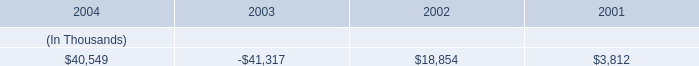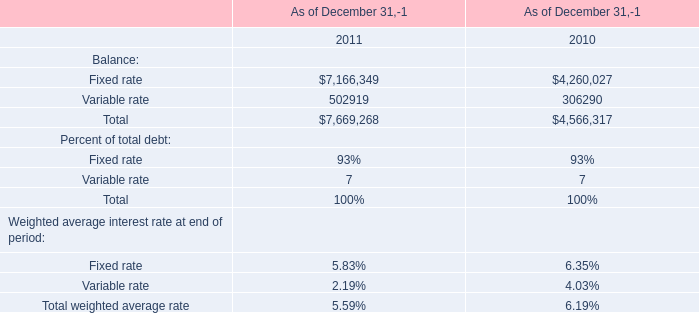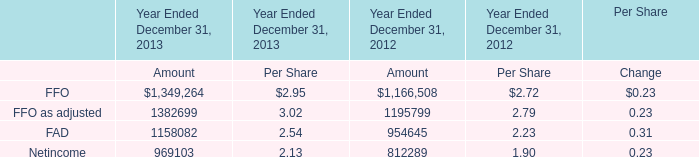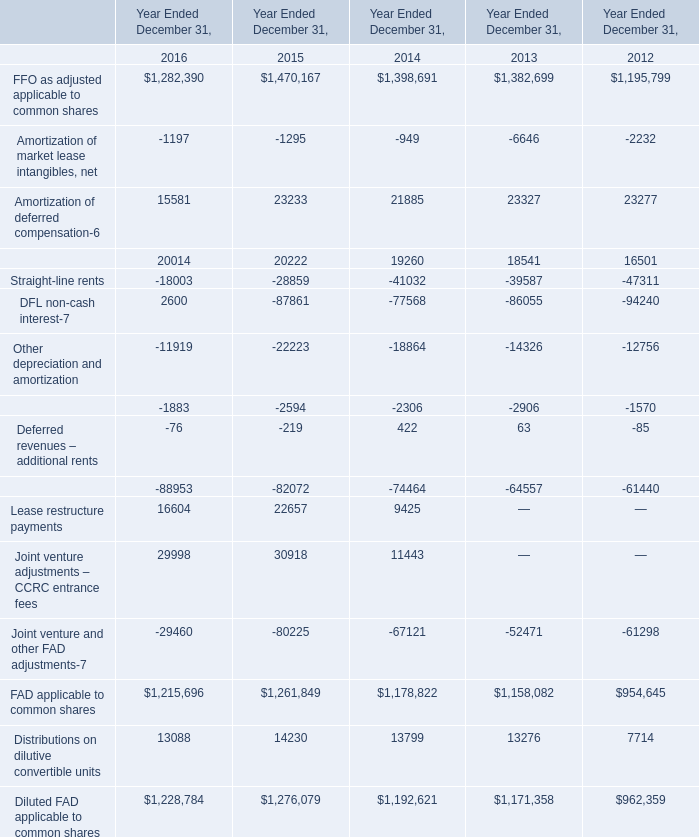What is the sum of Lease restructure payments of Year Ended December 31, 2015, and FAD of Year Ended December 31, 2012 Amount ? 
Computations: (22657.0 + 954645.0)
Answer: 977302.0. 